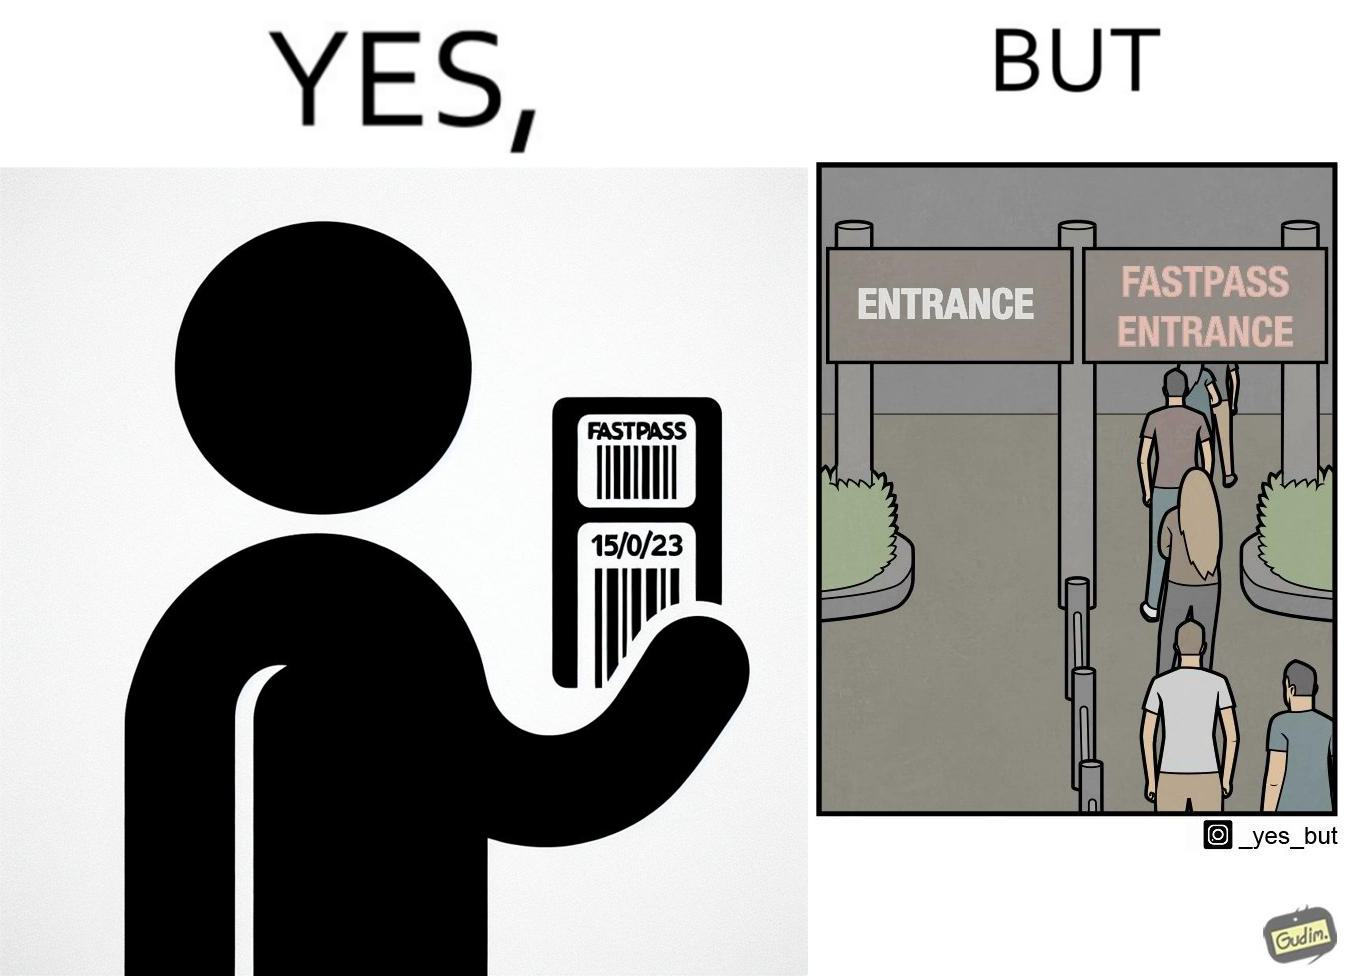What is shown in this image? The image is ironic, because fast pass entrance was meant for people to pass the gate fast but as more no. of people bought the pass due to which the queue has become longer and it becomes slow and time consuming 